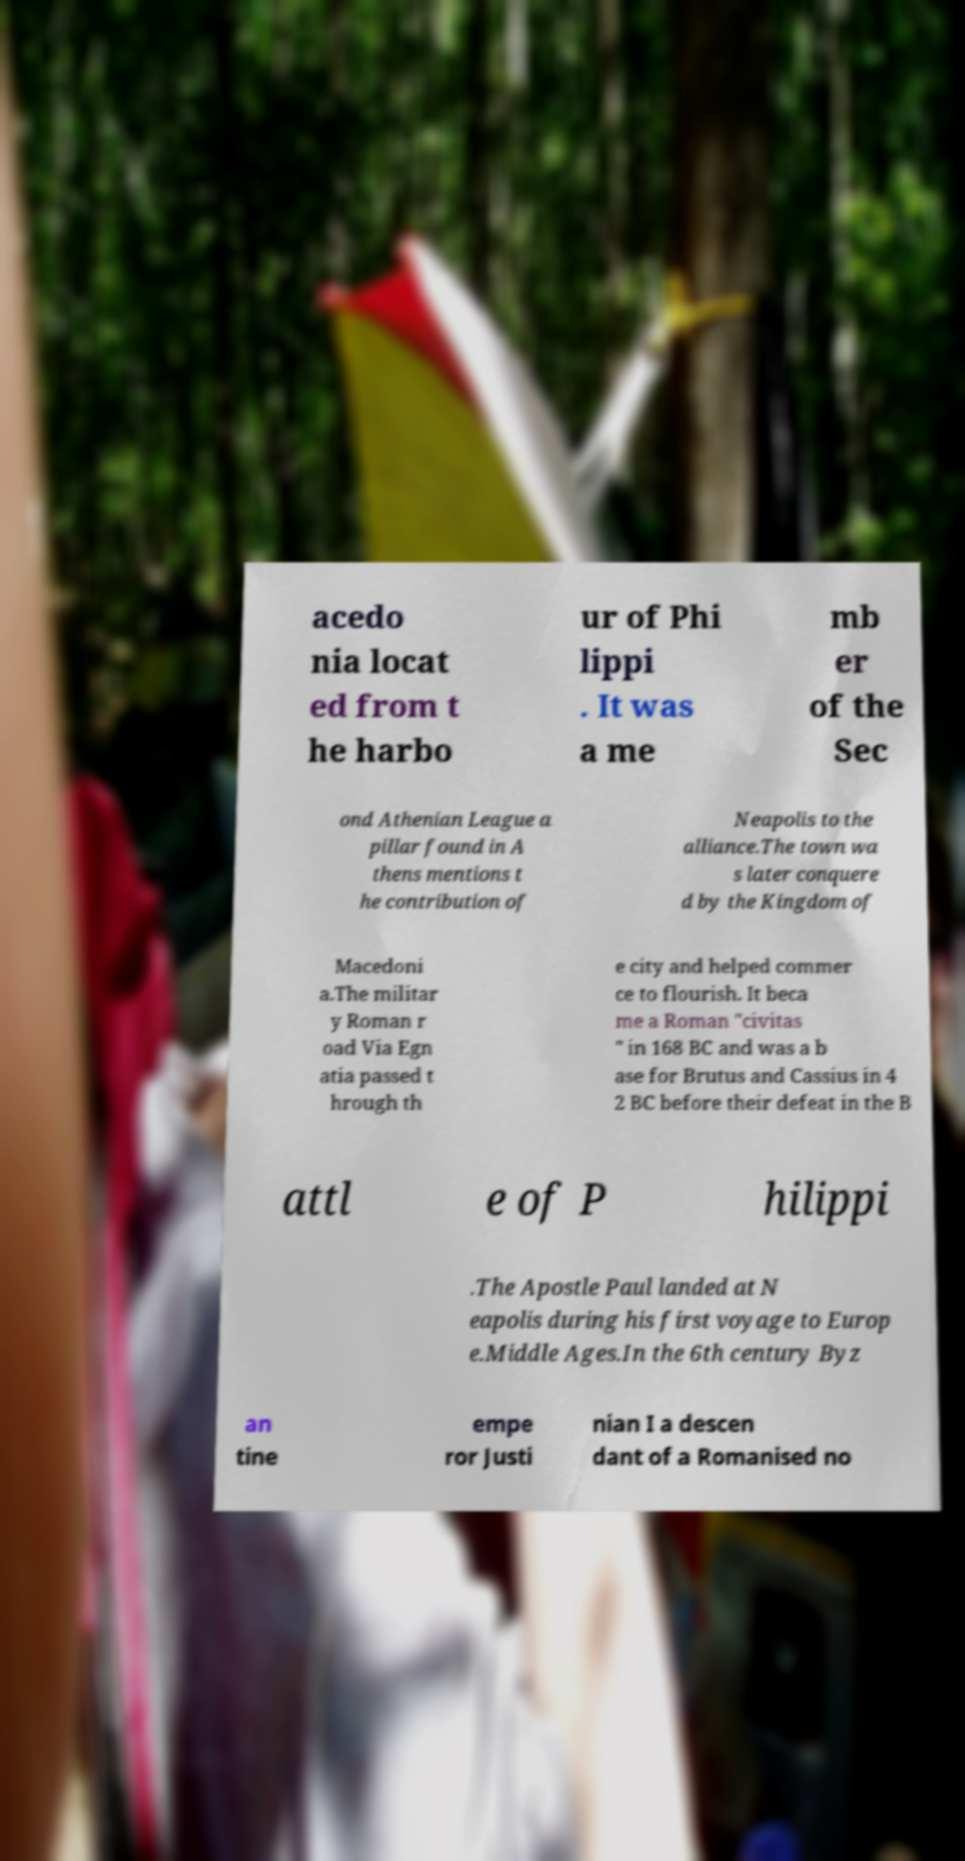There's text embedded in this image that I need extracted. Can you transcribe it verbatim? acedo nia locat ed from t he harbo ur of Phi lippi . It was a me mb er of the Sec ond Athenian League a pillar found in A thens mentions t he contribution of Neapolis to the alliance.The town wa s later conquere d by the Kingdom of Macedoni a.The militar y Roman r oad Via Egn atia passed t hrough th e city and helped commer ce to flourish. It beca me a Roman "civitas " in 168 BC and was a b ase for Brutus and Cassius in 4 2 BC before their defeat in the B attl e of P hilippi .The Apostle Paul landed at N eapolis during his first voyage to Europ e.Middle Ages.In the 6th century Byz an tine empe ror Justi nian I a descen dant of a Romanised no 